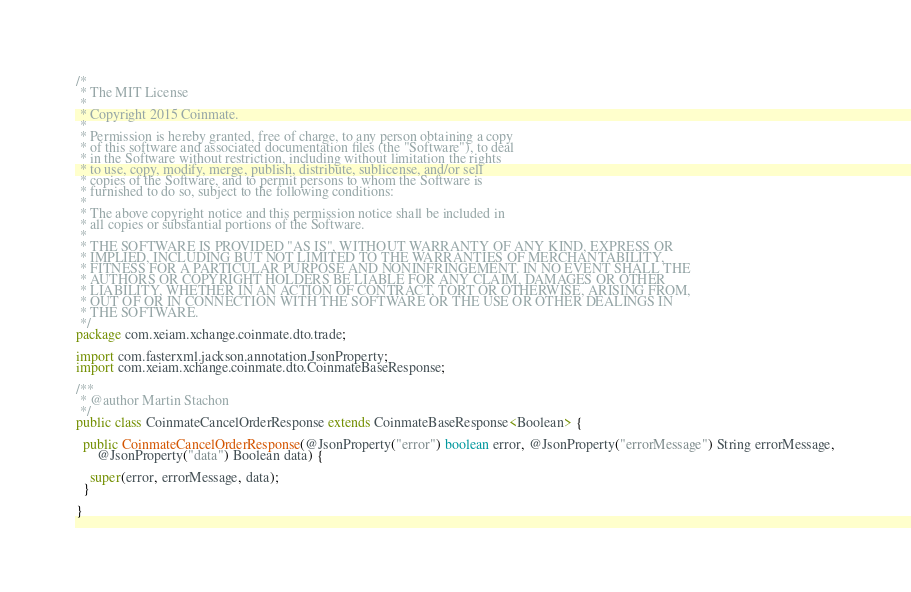<code> <loc_0><loc_0><loc_500><loc_500><_Java_>/*
 * The MIT License
 *
 * Copyright 2015 Coinmate.
 *
 * Permission is hereby granted, free of charge, to any person obtaining a copy
 * of this software and associated documentation files (the "Software"), to deal
 * in the Software without restriction, including without limitation the rights
 * to use, copy, modify, merge, publish, distribute, sublicense, and/or sell
 * copies of the Software, and to permit persons to whom the Software is
 * furnished to do so, subject to the following conditions:
 *
 * The above copyright notice and this permission notice shall be included in
 * all copies or substantial portions of the Software.
 *
 * THE SOFTWARE IS PROVIDED "AS IS", WITHOUT WARRANTY OF ANY KIND, EXPRESS OR
 * IMPLIED, INCLUDING BUT NOT LIMITED TO THE WARRANTIES OF MERCHANTABILITY,
 * FITNESS FOR A PARTICULAR PURPOSE AND NONINFRINGEMENT. IN NO EVENT SHALL THE
 * AUTHORS OR COPYRIGHT HOLDERS BE LIABLE FOR ANY CLAIM, DAMAGES OR OTHER
 * LIABILITY, WHETHER IN AN ACTION OF CONTRACT, TORT OR OTHERWISE, ARISING FROM,
 * OUT OF OR IN CONNECTION WITH THE SOFTWARE OR THE USE OR OTHER DEALINGS IN
 * THE SOFTWARE.
 */
package com.xeiam.xchange.coinmate.dto.trade;

import com.fasterxml.jackson.annotation.JsonProperty;
import com.xeiam.xchange.coinmate.dto.CoinmateBaseResponse;

/**
 * @author Martin Stachon
 */
public class CoinmateCancelOrderResponse extends CoinmateBaseResponse<Boolean> {

  public CoinmateCancelOrderResponse(@JsonProperty("error") boolean error, @JsonProperty("errorMessage") String errorMessage,
      @JsonProperty("data") Boolean data) {

    super(error, errorMessage, data);
  }

}
</code> 